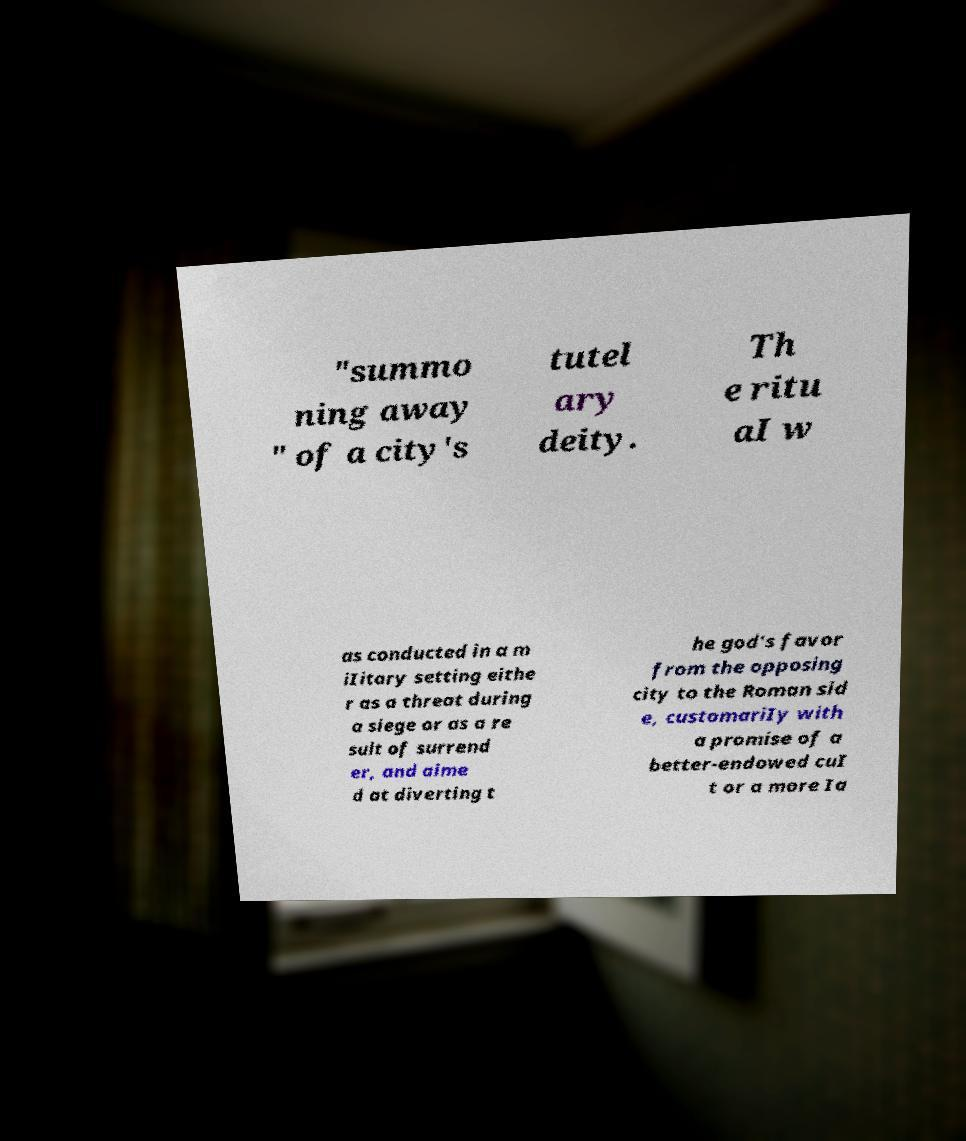For documentation purposes, I need the text within this image transcribed. Could you provide that? "summo ning away " of a city's tutel ary deity. Th e ritu aI w as conducted in a m iIitary setting eithe r as a threat during a siege or as a re sult of surrend er, and aime d at diverting t he god's favor from the opposing city to the Roman sid e, customariIy with a promise of a better-endowed cuI t or a more Ia 